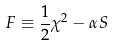Convert formula to latex. <formula><loc_0><loc_0><loc_500><loc_500>F \equiv \frac { 1 } { 2 } \chi ^ { 2 } - \alpha S</formula> 